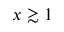Convert formula to latex. <formula><loc_0><loc_0><loc_500><loc_500>x \gtrsim 1</formula> 